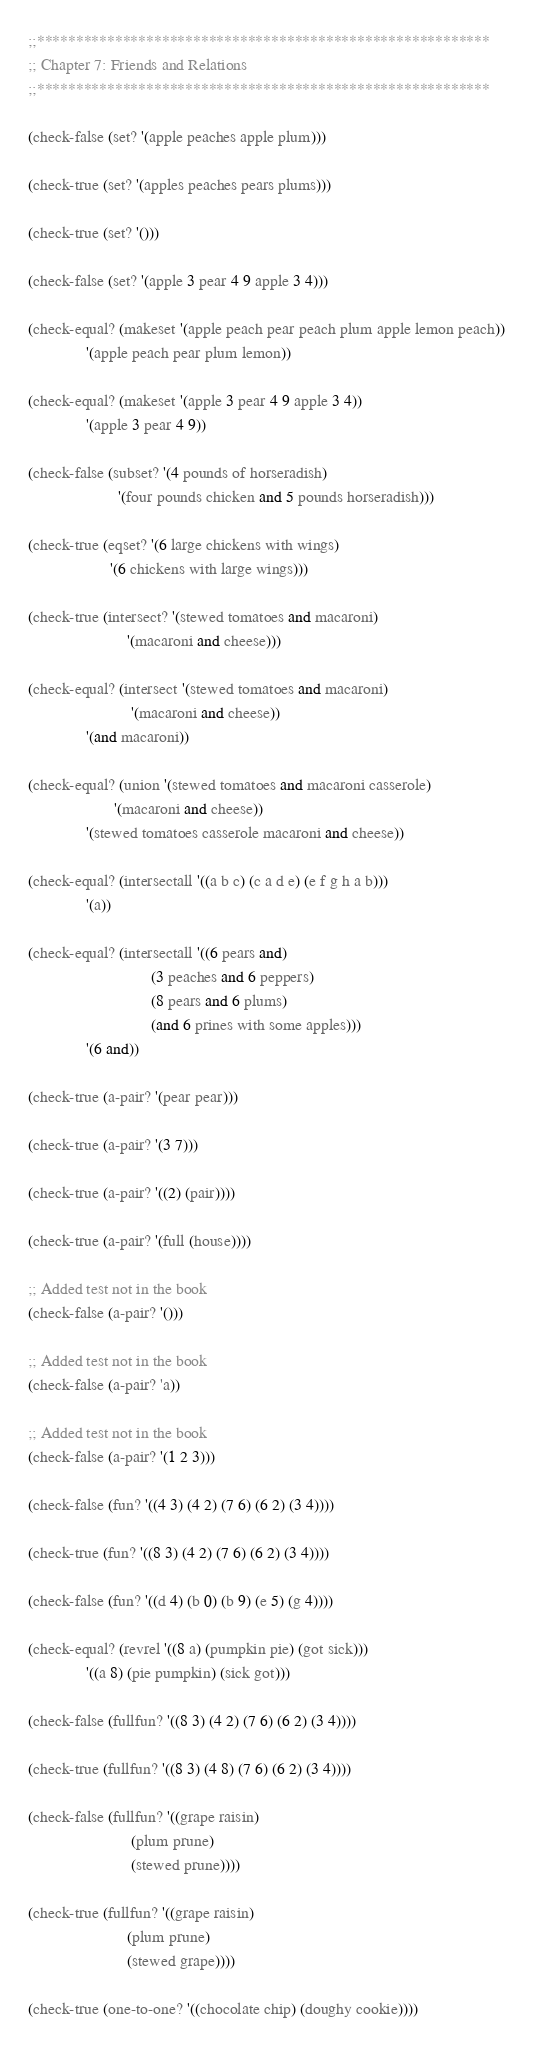<code> <loc_0><loc_0><loc_500><loc_500><_Scheme_>;;**********************************************************
;; Chapter 7: Friends and Relations
;;**********************************************************

(check-false (set? '(apple peaches apple plum)))

(check-true (set? '(apples peaches pears plums)))

(check-true (set? '()))

(check-false (set? '(apple 3 pear 4 9 apple 3 4)))

(check-equal? (makeset '(apple peach pear peach plum apple lemon peach))
              '(apple peach pear plum lemon))

(check-equal? (makeset '(apple 3 pear 4 9 apple 3 4))
              '(apple 3 pear 4 9))

(check-false (subset? '(4 pounds of horseradish)
                      '(four pounds chicken and 5 pounds horseradish)))

(check-true (eqset? '(6 large chickens with wings)
                    '(6 chickens with large wings)))

(check-true (intersect? '(stewed tomatoes and macaroni)
                        '(macaroni and cheese)))

(check-equal? (intersect '(stewed tomatoes and macaroni)
                         '(macaroni and cheese))
              '(and macaroni))

(check-equal? (union '(stewed tomatoes and macaroni casserole)
                     '(macaroni and cheese))
              '(stewed tomatoes casserole macaroni and cheese))

(check-equal? (intersectall '((a b c) (c a d e) (e f g h a b)))
              '(a))

(check-equal? (intersectall '((6 pears and)
                              (3 peaches and 6 peppers)
                              (8 pears and 6 plums)
                              (and 6 prines with some apples)))
              '(6 and))

(check-true (a-pair? '(pear pear)))

(check-true (a-pair? '(3 7)))

(check-true (a-pair? '((2) (pair))))

(check-true (a-pair? '(full (house))))

;; Added test not in the book
(check-false (a-pair? '()))

;; Added test not in the book
(check-false (a-pair? 'a))

;; Added test not in the book
(check-false (a-pair? '(1 2 3)))

(check-false (fun? '((4 3) (4 2) (7 6) (6 2) (3 4))))

(check-true (fun? '((8 3) (4 2) (7 6) (6 2) (3 4))))

(check-false (fun? '((d 4) (b 0) (b 9) (e 5) (g 4))))

(check-equal? (revrel '((8 a) (pumpkin pie) (got sick)))
              '((a 8) (pie pumpkin) (sick got)))

(check-false (fullfun? '((8 3) (4 2) (7 6) (6 2) (3 4))))

(check-true (fullfun? '((8 3) (4 8) (7 6) (6 2) (3 4))))

(check-false (fullfun? '((grape raisin)
                         (plum prune)
                         (stewed prune))))

(check-true (fullfun? '((grape raisin)
                        (plum prune)
                        (stewed grape))))

(check-true (one-to-one? '((chocolate chip) (doughy cookie))))
</code> 